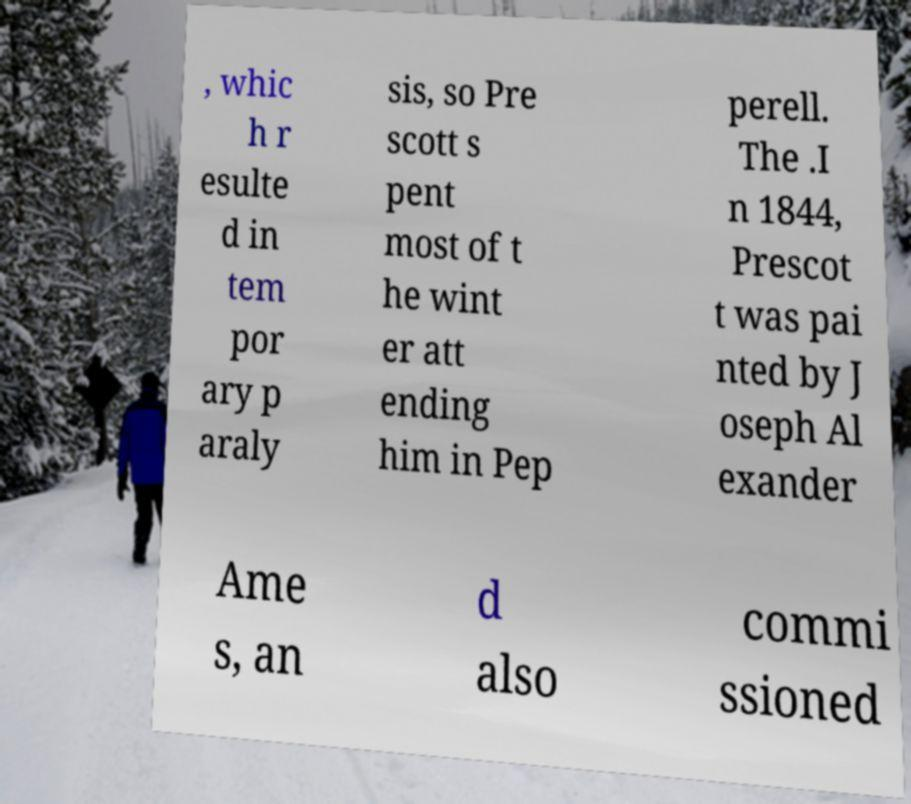What messages or text are displayed in this image? I need them in a readable, typed format. , whic h r esulte d in tem por ary p araly sis, so Pre scott s pent most of t he wint er att ending him in Pep perell. The .I n 1844, Prescot t was pai nted by J oseph Al exander Ame s, an d also commi ssioned 